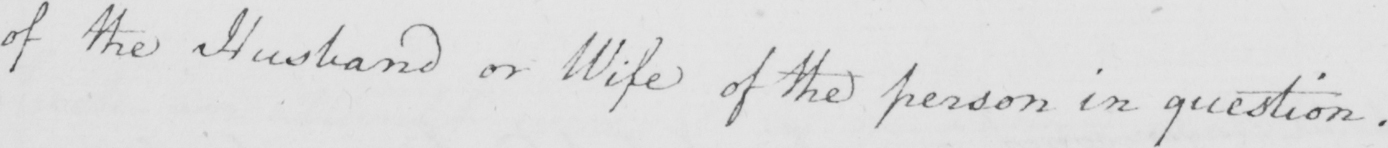What is written in this line of handwriting? of the Husband or Wife of the person in question . 